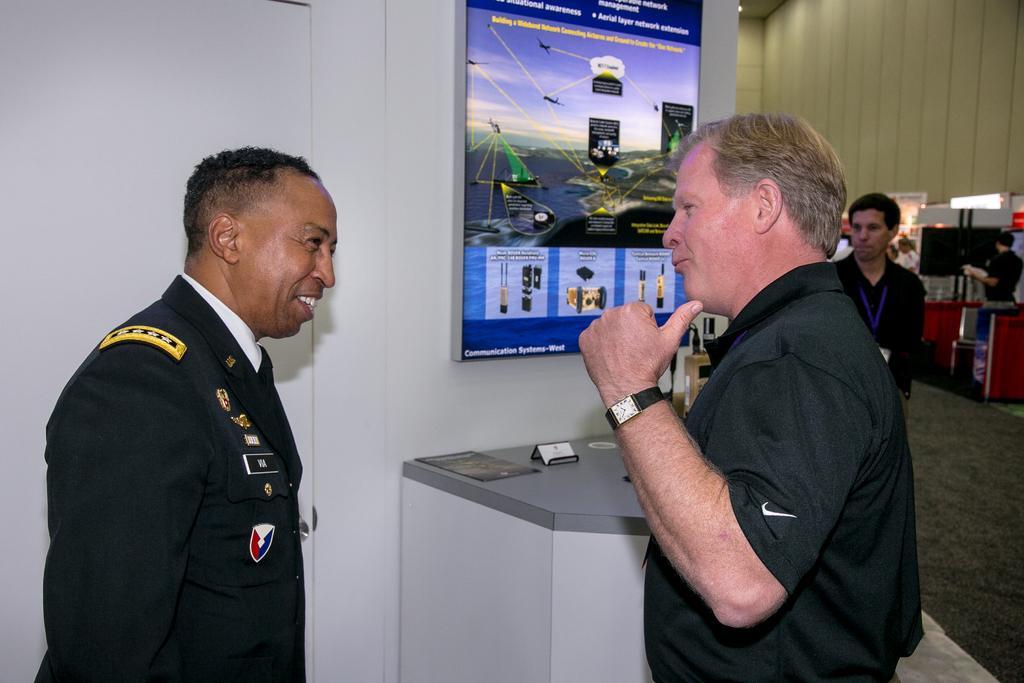In one or two sentences, can you explain what this image depicts? In this picture I can see the two persons in the middle, in the background it looks like a banner. On the right side I can see few persons. 